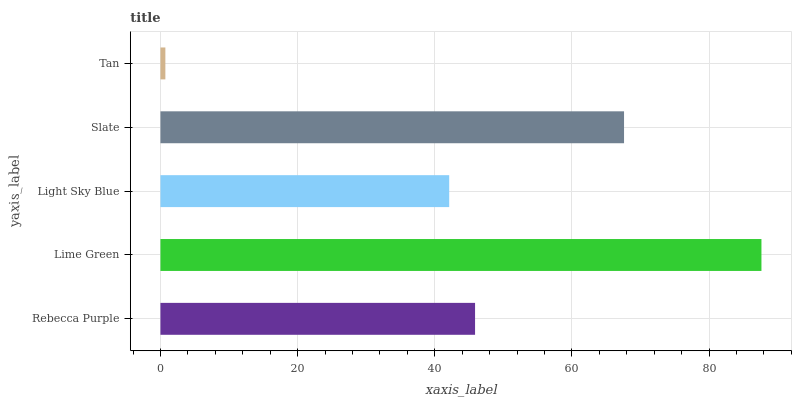Is Tan the minimum?
Answer yes or no. Yes. Is Lime Green the maximum?
Answer yes or no. Yes. Is Light Sky Blue the minimum?
Answer yes or no. No. Is Light Sky Blue the maximum?
Answer yes or no. No. Is Lime Green greater than Light Sky Blue?
Answer yes or no. Yes. Is Light Sky Blue less than Lime Green?
Answer yes or no. Yes. Is Light Sky Blue greater than Lime Green?
Answer yes or no. No. Is Lime Green less than Light Sky Blue?
Answer yes or no. No. Is Rebecca Purple the high median?
Answer yes or no. Yes. Is Rebecca Purple the low median?
Answer yes or no. Yes. Is Tan the high median?
Answer yes or no. No. Is Slate the low median?
Answer yes or no. No. 